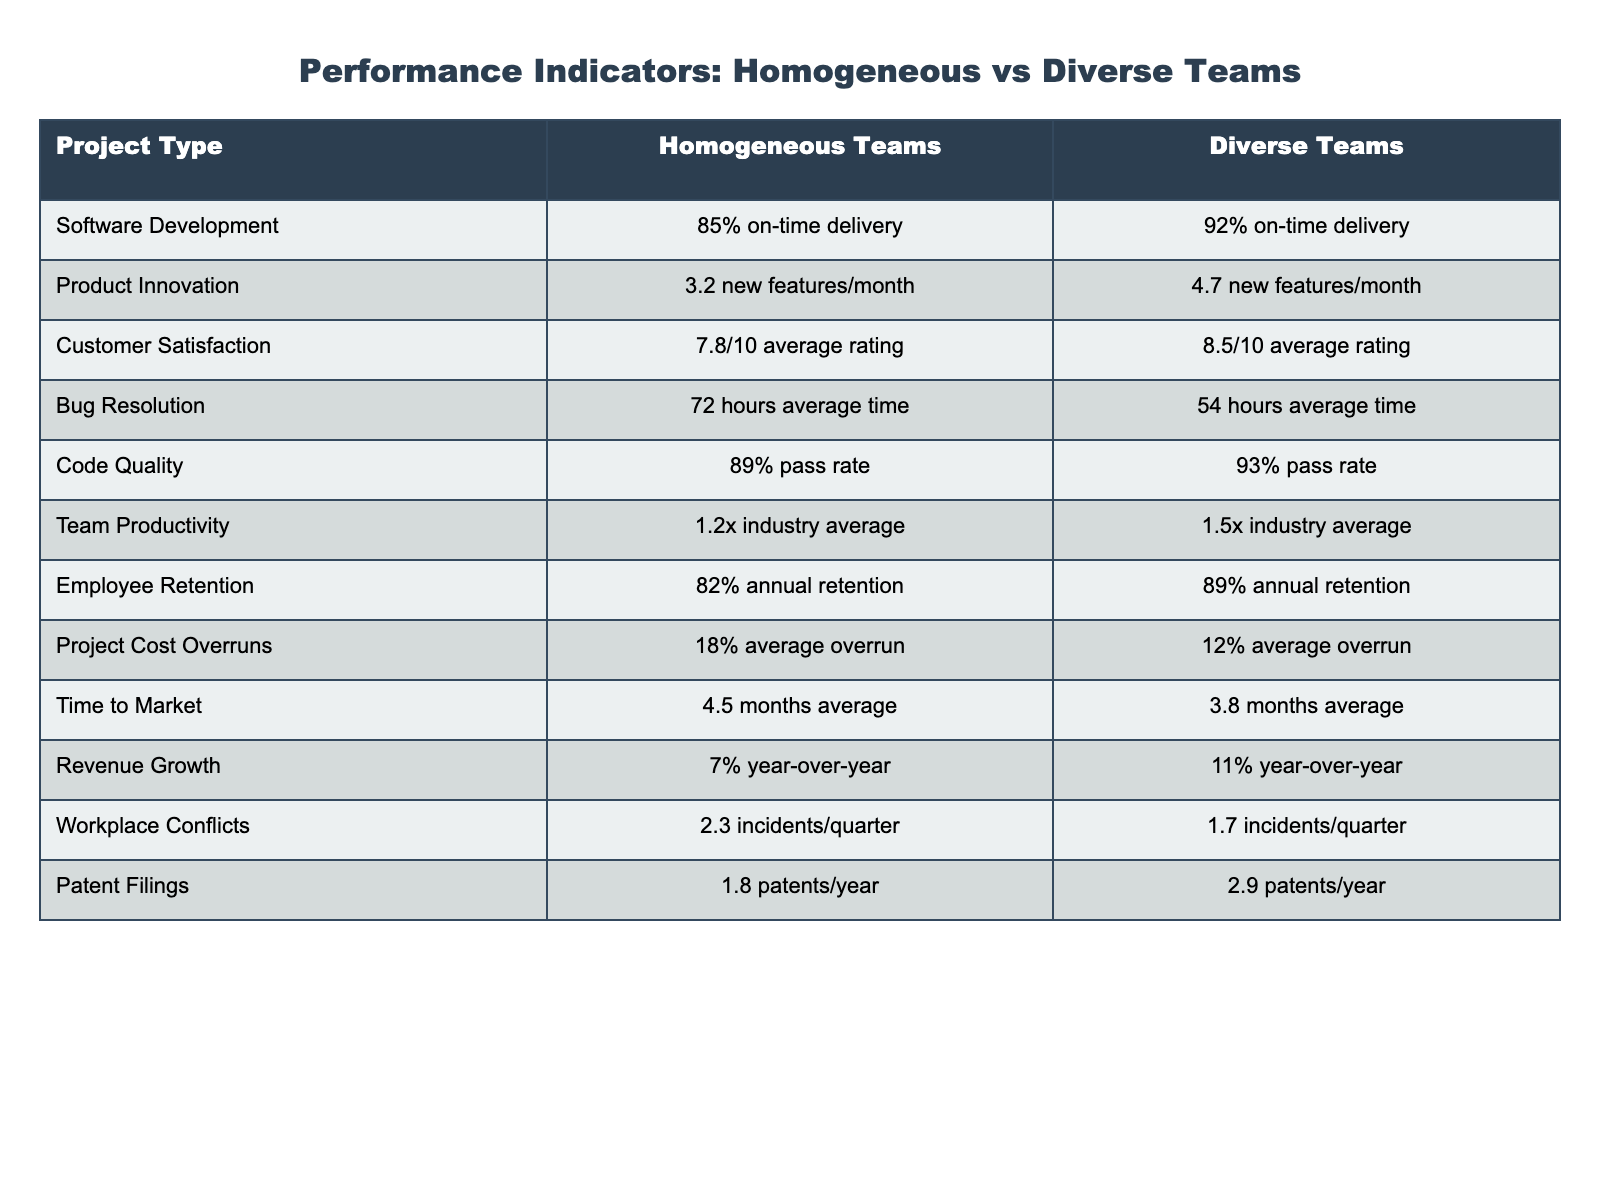What is the on-time delivery percentage for diverse teams? The table shows that the on-time delivery for diverse teams is listed as 92%.
Answer: 92% How much quicker is the bug resolution time for diverse teams compared to homogeneous teams? The average bug resolution time for homogeneous teams is 72 hours, and for diverse teams, it is 54 hours. The difference is 72 - 54 = 18 hours.
Answer: 18 hours True or False: Diverse teams have a higher average customer satisfaction rating than homogeneous teams. According to the table, diverse teams have an average rating of 8.5/10, while homogeneous teams have 7.8/10, confirming the statement as True.
Answer: True What is the average time to market for homogeneous teams compared to diverse teams, and which team type has a shorter time? The average time to market for homogeneous teams is 4.5 months, while for diverse teams, it is 3.8 months. Capturing the difference shows that diverse teams have a shorter time to market.
Answer: Diverse teams have a shorter time to market Calculate the percentage difference in annual employee retention between homogeneous and diverse teams. The retention for homogeneous teams is 82%, and for diverse teams, it is 89%. The percentage difference can be calculated as: ((89 - 82) / 82) * 100 = 8.54%.
Answer: 8.54% Which team type demonstrates higher productivity according to the table? The table indicates that diverse teams have a productivity rating of 1.5x industry average while homogeneous teams have 1.2x. This shows that diverse teams demonstrate higher productivity.
Answer: Diverse teams demonstrate higher productivity What's the total number of patents filed by diverse teams compared to homogeneous teams? The number of patents filed by homogeneous teams is 1.8 patents/year, while diverse teams file 2.9 patents/year. The totals align as 1.8 for homogeneous and 2.9 for diverse teams.
Answer: 1.8 (homogeneous), 2.9 (diverse) How many fewer workplace conflicts occur in diverse teams compared to homogeneous teams? The number of workplace conflicts for homogeneous teams is 2.3 incidents/quarter, while for diverse teams it is 1.7. The difference is 2.3 - 1.7 = 0.6 incidents/quarter.
Answer: 0.6 incidents/quarter What is the difference in revenue growth percentage between homogeneous and diverse teams? The revenue growth for homogeneous teams is 7% and for diverse teams, it is 11%. The difference is 11 - 7 = 4%.
Answer: 4% Which project type has the highest average code quality rating? For code quality, the ratings are 89% for homogeneous teams and 93% for diverse teams; comparing them shows that diverse teams have the highest average rating.
Answer: Diverse teams have the highest average code quality rating How can we summarize the overall performance of diverse teams compared to homogeneous teams based on the data? Diverse teams consistently outperform homogeneous teams in multiple metrics such as on-time delivery, customer satisfaction, bug resolution time, patent filings, and retention rates, indicating their overall superior performance in tech projects.
Answer: Diverse teams outperform homogeneous teams overall 